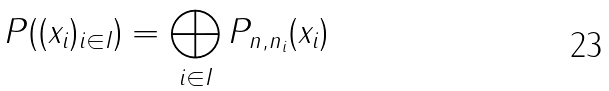Convert formula to latex. <formula><loc_0><loc_0><loc_500><loc_500>P ( ( x _ { i } ) _ { i \in I } ) = \bigoplus _ { i \in I } P _ { n , n _ { i } } ( x _ { i } )</formula> 